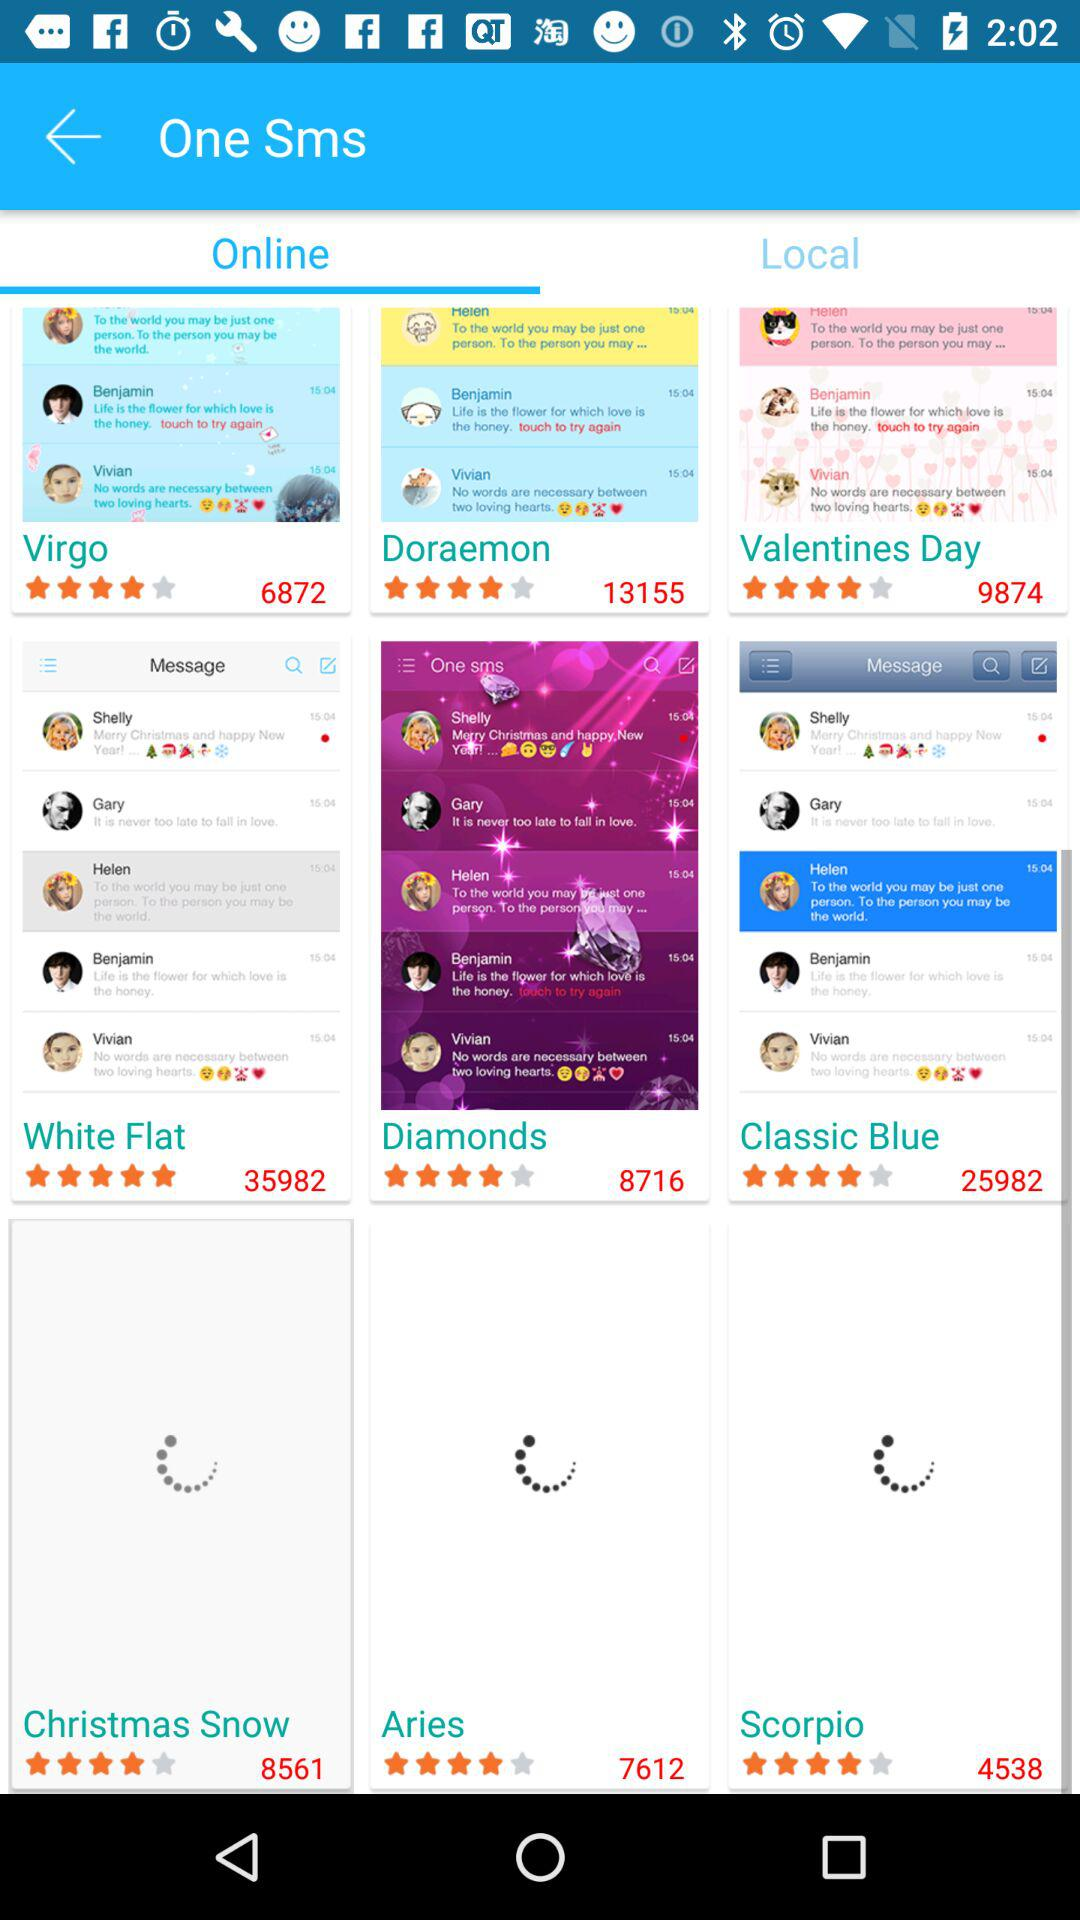How many stars did the "Diamonds" get? The "Diamonds" get 4 stars. 